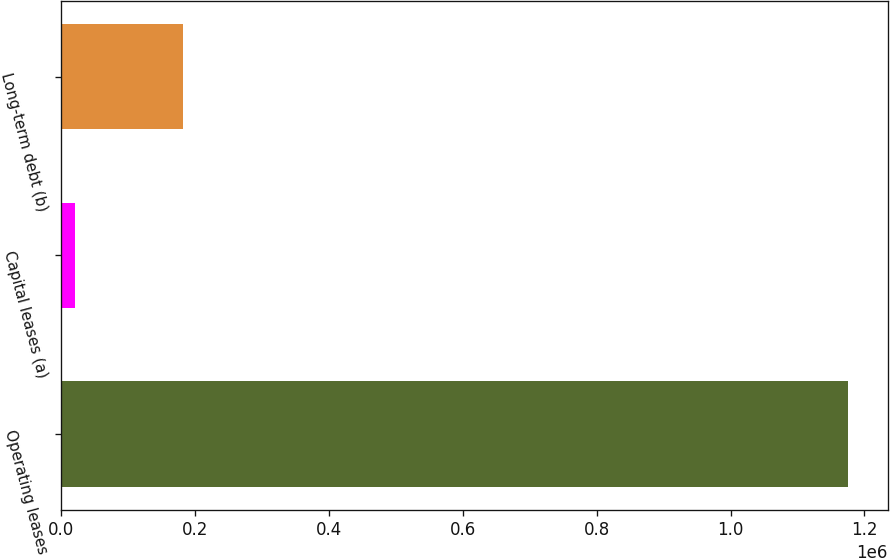<chart> <loc_0><loc_0><loc_500><loc_500><bar_chart><fcel>Operating leases<fcel>Capital leases (a)<fcel>Long-term debt (b)<nl><fcel>1.17597e+06<fcel>20169<fcel>181234<nl></chart> 